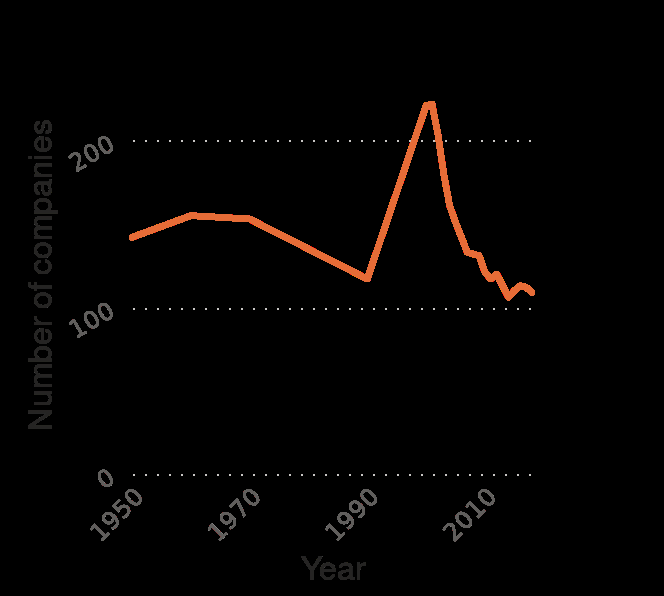<image>
What is the title of the line graph?  The title of the line graph is "Number of mutual life insurance companies in the United States from 1950 to 2018". 